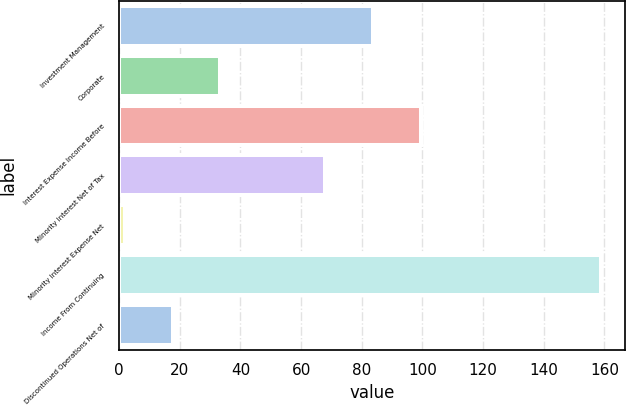Convert chart. <chart><loc_0><loc_0><loc_500><loc_500><bar_chart><fcel>Investment Management<fcel>Corporate<fcel>Interest Expense Income Before<fcel>Minority Interest Net of Tax<fcel>Minority Interest Expense Net<fcel>Income From Continuing<fcel>Discontinued Operations Net of<nl><fcel>83.7<fcel>33.4<fcel>99.4<fcel>68<fcel>2<fcel>159<fcel>17.7<nl></chart> 